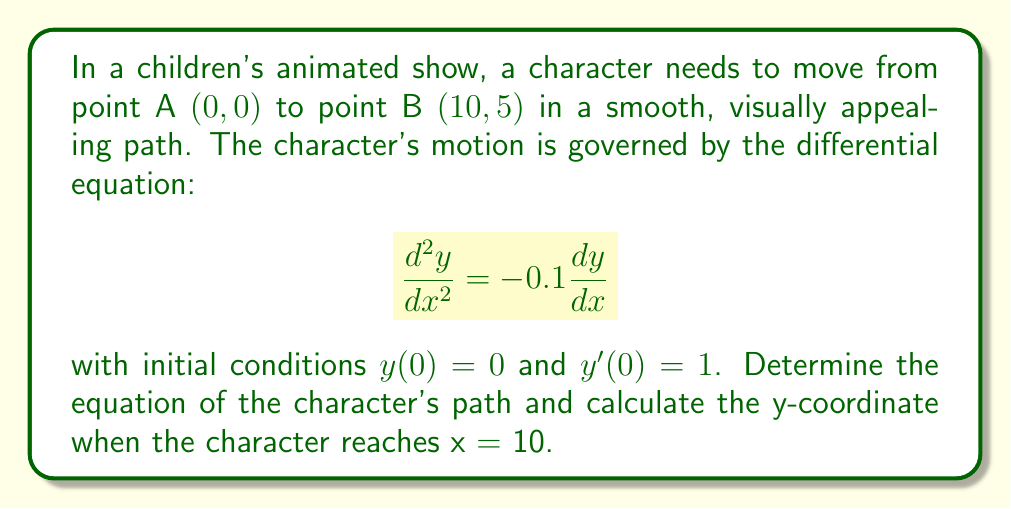Can you answer this question? To solve this problem, we'll follow these steps:

1) First, we need to solve the given second-order differential equation:
   $$\frac{d^2y}{dx^2} = -0.1\frac{dy}{dx}$$

2) Let $u = \frac{dy}{dx}$. Then $\frac{d^2y}{dx^2} = \frac{du}{dx}$. 
   Our equation becomes:
   $$\frac{du}{dx} = -0.1u$$

3) This is a separable first-order equation. Solving it:
   $$\int \frac{du}{u} = -0.1 \int dx$$
   $$\ln|u| = -0.1x + C_1$$
   $$u = C e^{-0.1x}$$

4) Since $u = \frac{dy}{dx}$, we can write:
   $$\frac{dy}{dx} = C e^{-0.1x}$$

5) Integrating both sides:
   $$y = -10C e^{-0.1x} + D$$

6) Now we use the initial conditions:
   $y(0) = 0$ gives us: $0 = -10C + D$, so $D = 10C$
   $y'(0) = 1$ gives us: $1 = C$

7) Substituting these values:
   $$y = 10 - 10e^{-0.1x}$$

8) This is the equation of the character's path.

9) To find y when x = 10, we simply substitute:
   $$y = 10 - 10e^{-0.1(10)} = 10 - 10e^{-1} \approx 6.32$$
Answer: The equation of the character's path is $y = 10 - 10e^{-0.1x}$, and when the character reaches x = 10, the y-coordinate is approximately 6.32. 